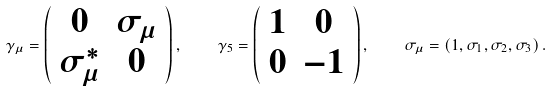<formula> <loc_0><loc_0><loc_500><loc_500>\gamma _ { \mu } = \left ( \begin{array} { c c } 0 & \sigma _ { \mu } \\ \sigma _ { \mu } ^ { \ast } & 0 \end{array} \right ) , \quad \gamma _ { 5 } = \left ( \begin{array} { c c } 1 & 0 \\ 0 & - 1 \end{array} \right ) , \quad \sigma _ { \mu } = \left ( 1 , \sigma _ { 1 } , \sigma _ { 2 } , \sigma _ { 3 } \right ) .</formula> 